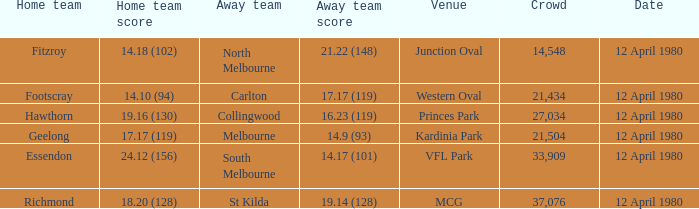Where did Essendon play as the home team? VFL Park. 